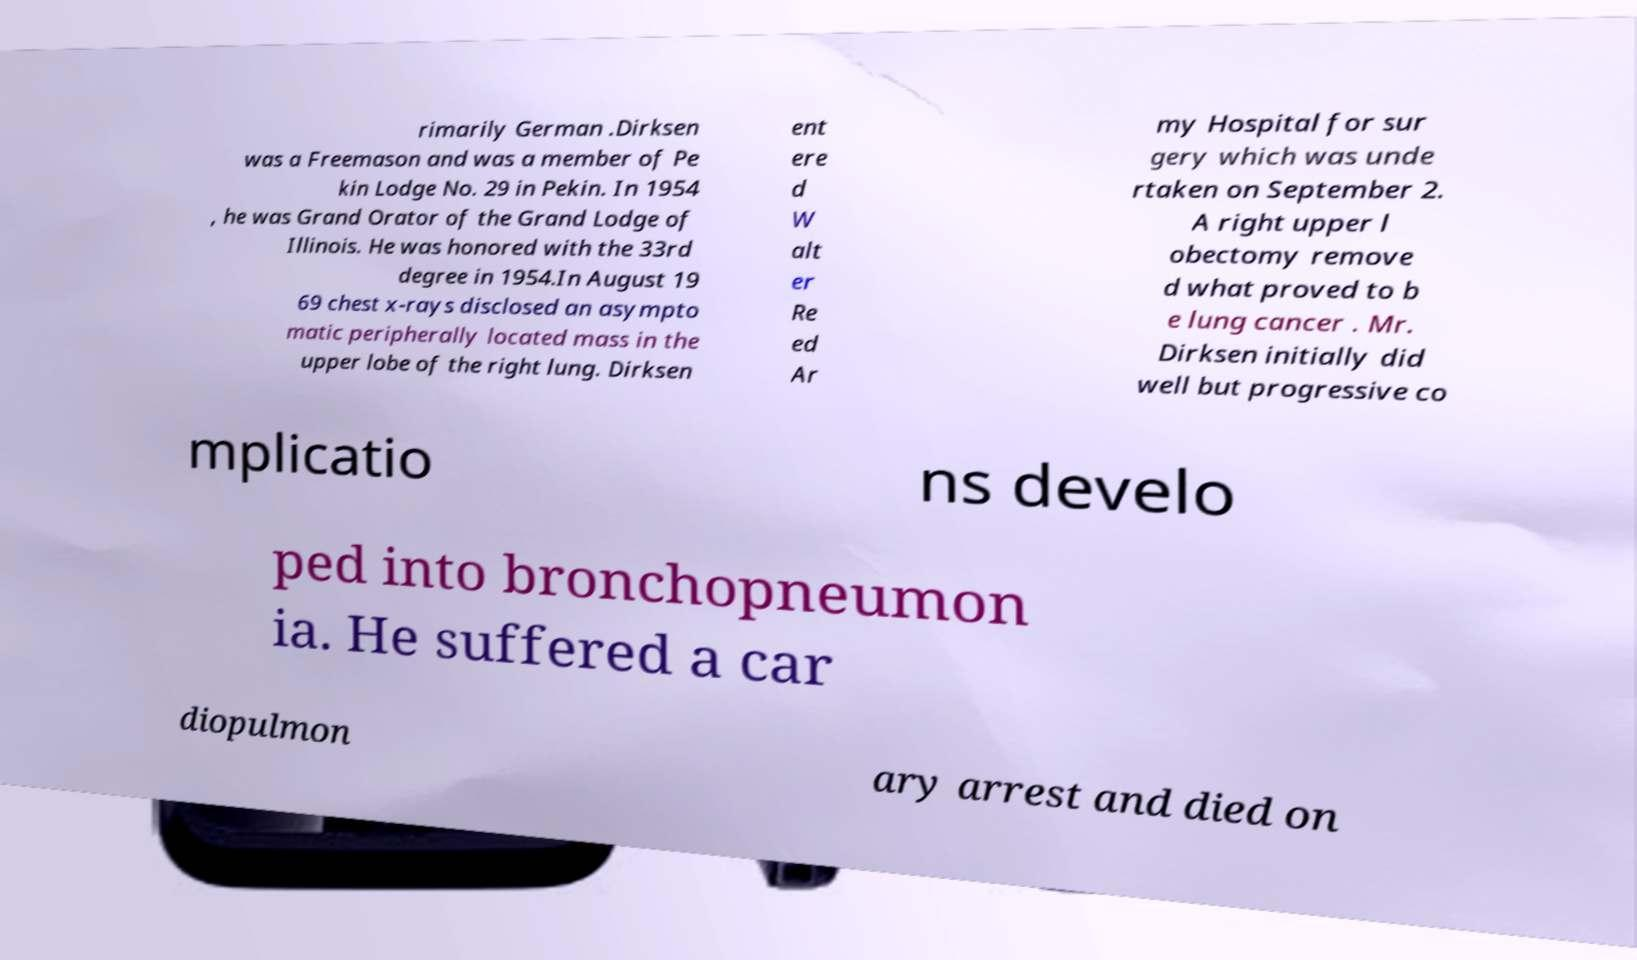Please identify and transcribe the text found in this image. rimarily German .Dirksen was a Freemason and was a member of Pe kin Lodge No. 29 in Pekin. In 1954 , he was Grand Orator of the Grand Lodge of Illinois. He was honored with the 33rd degree in 1954.In August 19 69 chest x-rays disclosed an asympto matic peripherally located mass in the upper lobe of the right lung. Dirksen ent ere d W alt er Re ed Ar my Hospital for sur gery which was unde rtaken on September 2. A right upper l obectomy remove d what proved to b e lung cancer . Mr. Dirksen initially did well but progressive co mplicatio ns develo ped into bronchopneumon ia. He suffered a car diopulmon ary arrest and died on 